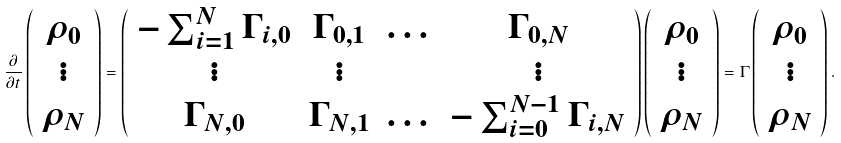<formula> <loc_0><loc_0><loc_500><loc_500>\frac { \partial } { \partial t } \left ( \begin{array} { c } \rho _ { 0 } \\ \vdots \\ \rho _ { N } \\ \end{array} \right ) = \left ( \begin{array} { c c c c } - \sum _ { i = 1 } ^ { N } \Gamma _ { i , 0 } & \Gamma _ { 0 , 1 } & \dots & \Gamma _ { 0 , N } \\ \vdots & \vdots & & \vdots \\ \Gamma _ { N , 0 } & \Gamma _ { N , 1 } & \dots & - \sum _ { i = 0 } ^ { N - 1 } \Gamma _ { i , N } \\ \end{array} \right ) \left ( \begin{array} { c } \rho _ { 0 } \\ \vdots \\ \rho _ { N } \\ \end{array} \right ) = \Gamma \left ( \begin{array} { c } \rho _ { 0 } \\ \vdots \\ \rho _ { N } \\ \end{array} \right ) .</formula> 